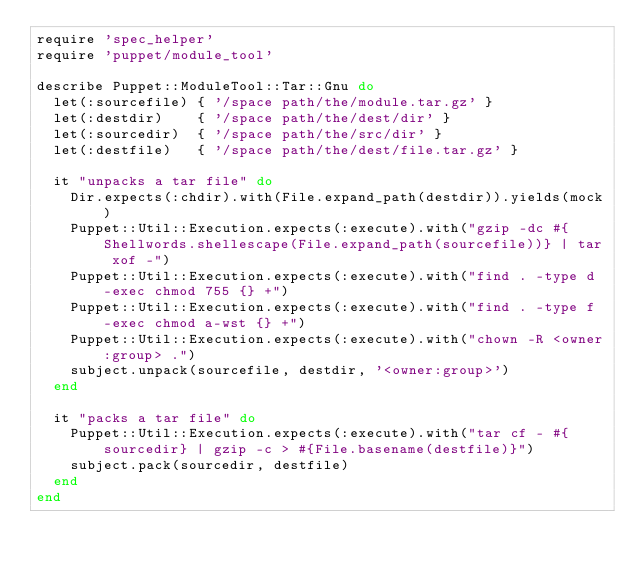<code> <loc_0><loc_0><loc_500><loc_500><_Ruby_>require 'spec_helper'
require 'puppet/module_tool'

describe Puppet::ModuleTool::Tar::Gnu do
  let(:sourcefile) { '/space path/the/module.tar.gz' }
  let(:destdir)    { '/space path/the/dest/dir' }
  let(:sourcedir)  { '/space path/the/src/dir' }
  let(:destfile)   { '/space path/the/dest/file.tar.gz' }

  it "unpacks a tar file" do
    Dir.expects(:chdir).with(File.expand_path(destdir)).yields(mock)
    Puppet::Util::Execution.expects(:execute).with("gzip -dc #{Shellwords.shellescape(File.expand_path(sourcefile))} | tar xof -")
    Puppet::Util::Execution.expects(:execute).with("find . -type d -exec chmod 755 {} +")
    Puppet::Util::Execution.expects(:execute).with("find . -type f -exec chmod a-wst {} +")
    Puppet::Util::Execution.expects(:execute).with("chown -R <owner:group> .")
    subject.unpack(sourcefile, destdir, '<owner:group>')
  end

  it "packs a tar file" do
    Puppet::Util::Execution.expects(:execute).with("tar cf - #{sourcedir} | gzip -c > #{File.basename(destfile)}")
    subject.pack(sourcedir, destfile)
  end
end
</code> 